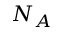Convert formula to latex. <formula><loc_0><loc_0><loc_500><loc_500>N _ { A }</formula> 